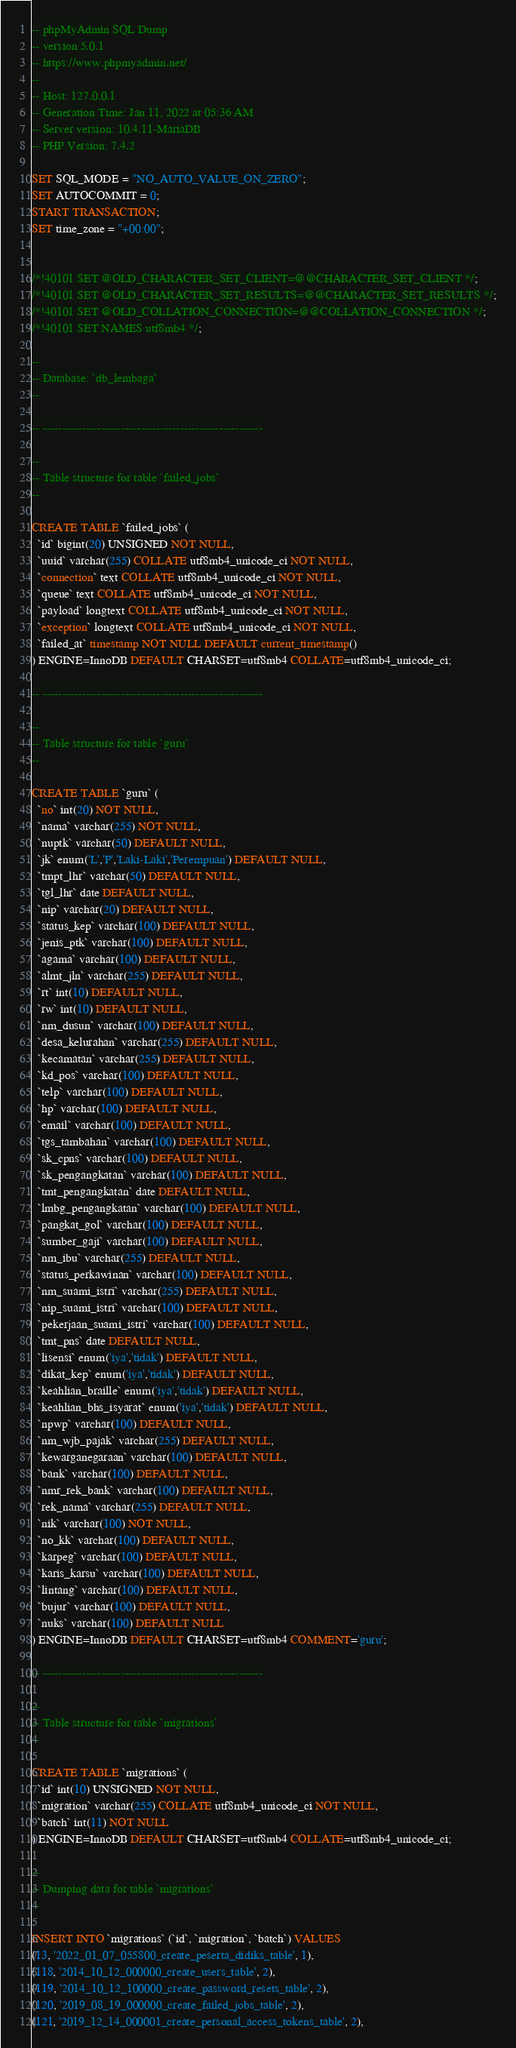<code> <loc_0><loc_0><loc_500><loc_500><_SQL_>-- phpMyAdmin SQL Dump
-- version 5.0.1
-- https://www.phpmyadmin.net/
--
-- Host: 127.0.0.1
-- Generation Time: Jan 11, 2022 at 05:36 AM
-- Server version: 10.4.11-MariaDB
-- PHP Version: 7.4.2

SET SQL_MODE = "NO_AUTO_VALUE_ON_ZERO";
SET AUTOCOMMIT = 0;
START TRANSACTION;
SET time_zone = "+00:00";


/*!40101 SET @OLD_CHARACTER_SET_CLIENT=@@CHARACTER_SET_CLIENT */;
/*!40101 SET @OLD_CHARACTER_SET_RESULTS=@@CHARACTER_SET_RESULTS */;
/*!40101 SET @OLD_COLLATION_CONNECTION=@@COLLATION_CONNECTION */;
/*!40101 SET NAMES utf8mb4 */;

--
-- Database: `db_lembaga`
--

-- --------------------------------------------------------

--
-- Table structure for table `failed_jobs`
--

CREATE TABLE `failed_jobs` (
  `id` bigint(20) UNSIGNED NOT NULL,
  `uuid` varchar(255) COLLATE utf8mb4_unicode_ci NOT NULL,
  `connection` text COLLATE utf8mb4_unicode_ci NOT NULL,
  `queue` text COLLATE utf8mb4_unicode_ci NOT NULL,
  `payload` longtext COLLATE utf8mb4_unicode_ci NOT NULL,
  `exception` longtext COLLATE utf8mb4_unicode_ci NOT NULL,
  `failed_at` timestamp NOT NULL DEFAULT current_timestamp()
) ENGINE=InnoDB DEFAULT CHARSET=utf8mb4 COLLATE=utf8mb4_unicode_ci;

-- --------------------------------------------------------

--
-- Table structure for table `guru`
--

CREATE TABLE `guru` (
  `no` int(20) NOT NULL,
  `nama` varchar(255) NOT NULL,
  `nuptk` varchar(50) DEFAULT NULL,
  `jk` enum('L','P','Laki-Laki','Perempuan') DEFAULT NULL,
  `tmpt_lhr` varchar(50) DEFAULT NULL,
  `tgl_lhr` date DEFAULT NULL,
  `nip` varchar(20) DEFAULT NULL,
  `status_kep` varchar(100) DEFAULT NULL,
  `jenis_ptk` varchar(100) DEFAULT NULL,
  `agama` varchar(100) DEFAULT NULL,
  `almt_jln` varchar(255) DEFAULT NULL,
  `rt` int(10) DEFAULT NULL,
  `rw` int(10) DEFAULT NULL,
  `nm_dusun` varchar(100) DEFAULT NULL,
  `desa_kelurahan` varchar(255) DEFAULT NULL,
  `kecamatan` varchar(255) DEFAULT NULL,
  `kd_pos` varchar(100) DEFAULT NULL,
  `telp` varchar(100) DEFAULT NULL,
  `hp` varchar(100) DEFAULT NULL,
  `email` varchar(100) DEFAULT NULL,
  `tgs_tambahan` varchar(100) DEFAULT NULL,
  `sk_cpns` varchar(100) DEFAULT NULL,
  `sk_pengangkatan` varchar(100) DEFAULT NULL,
  `tmt_pengangkatan` date DEFAULT NULL,
  `lmbg_pengangkatan` varchar(100) DEFAULT NULL,
  `pangkat_gol` varchar(100) DEFAULT NULL,
  `sumber_gaji` varchar(100) DEFAULT NULL,
  `nm_ibu` varchar(255) DEFAULT NULL,
  `status_perkawinan` varchar(100) DEFAULT NULL,
  `nm_suami_istri` varchar(255) DEFAULT NULL,
  `nip_suami_istri` varchar(100) DEFAULT NULL,
  `pekerjaan_suami_istri` varchar(100) DEFAULT NULL,
  `tmt_pns` date DEFAULT NULL,
  `lisensi` enum('iya','tidak') DEFAULT NULL,
  `dikat_kep` enum('iya','tidak') DEFAULT NULL,
  `keahlian_braille` enum('iya','tidak') DEFAULT NULL,
  `keahlian_bhs_isyarat` enum('iya','tidak') DEFAULT NULL,
  `npwp` varchar(100) DEFAULT NULL,
  `nm_wjb_pajak` varchar(255) DEFAULT NULL,
  `kewarganegaraan` varchar(100) DEFAULT NULL,
  `bank` varchar(100) DEFAULT NULL,
  `nmr_rek_bank` varchar(100) DEFAULT NULL,
  `rek_nama` varchar(255) DEFAULT NULL,
  `nik` varchar(100) NOT NULL,
  `no_kk` varchar(100) DEFAULT NULL,
  `karpeg` varchar(100) DEFAULT NULL,
  `karis_karsu` varchar(100) DEFAULT NULL,
  `lintang` varchar(100) DEFAULT NULL,
  `bujur` varchar(100) DEFAULT NULL,
  `nuks` varchar(100) DEFAULT NULL
) ENGINE=InnoDB DEFAULT CHARSET=utf8mb4 COMMENT='guru';

-- --------------------------------------------------------

--
-- Table structure for table `migrations`
--

CREATE TABLE `migrations` (
  `id` int(10) UNSIGNED NOT NULL,
  `migration` varchar(255) COLLATE utf8mb4_unicode_ci NOT NULL,
  `batch` int(11) NOT NULL
) ENGINE=InnoDB DEFAULT CHARSET=utf8mb4 COLLATE=utf8mb4_unicode_ci;

--
-- Dumping data for table `migrations`
--

INSERT INTO `migrations` (`id`, `migration`, `batch`) VALUES
(13, '2022_01_07_055800_create_peserta_didiks_table', 1),
(118, '2014_10_12_000000_create_users_table', 2),
(119, '2014_10_12_100000_create_password_resets_table', 2),
(120, '2019_08_19_000000_create_failed_jobs_table', 2),
(121, '2019_12_14_000001_create_personal_access_tokens_table', 2),</code> 